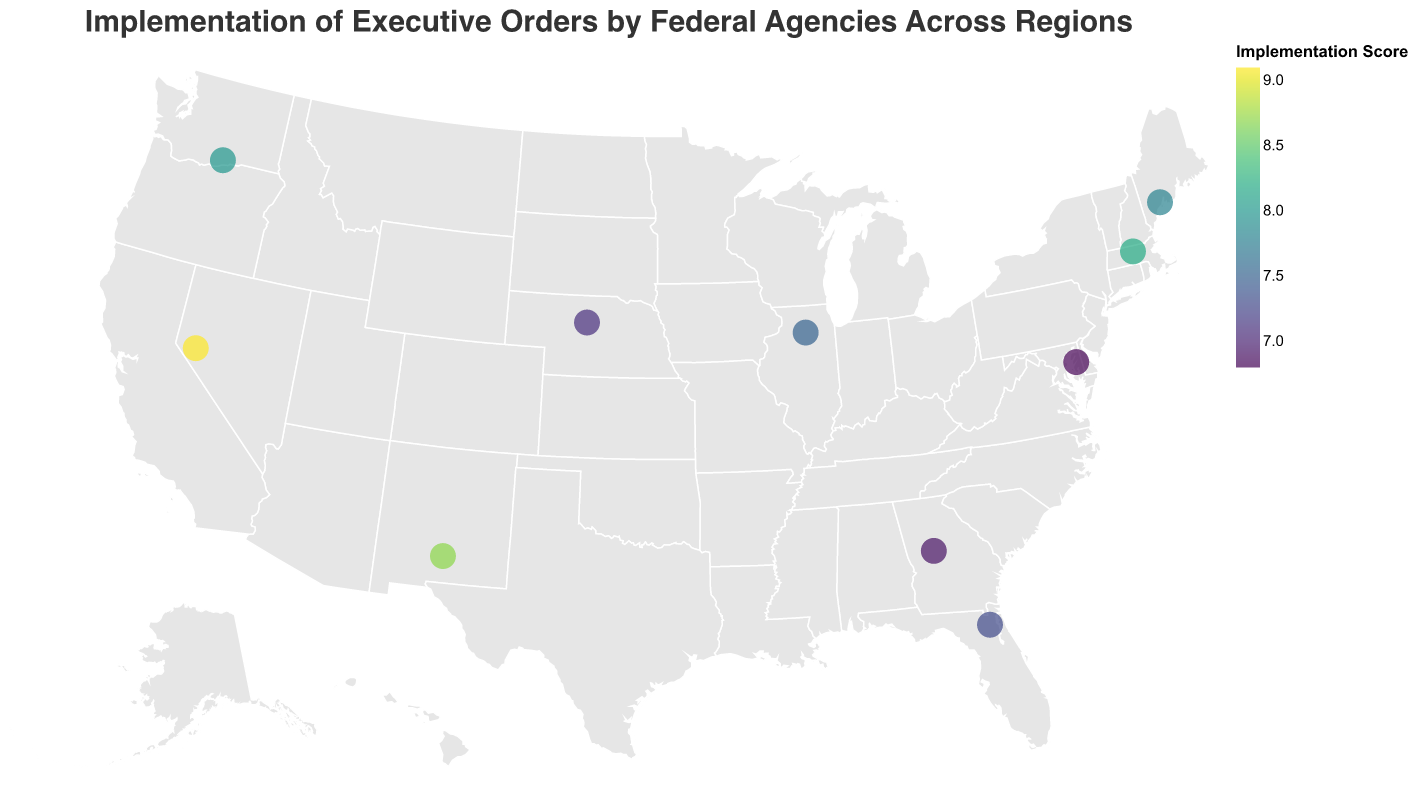what is the title of the plot? The title is usually displayed at the top of the plot. Here, it indicates the main topic, which is the implementation of executive orders by federal agencies across different regions.
Answer: Implementation of Executive Orders by Federal Agencies Across Regions How many data points are plotted on the map? Counting the number of circles on the map, each representing a data point, leads to finding the total number.
Answer: 10 Which agency has the highest implementation score and in which region is it located? The color intensity and tooltip can indicate the highest implementation score, which belongs to the Department of the Interior in the West region.
Answer: Department of the Interior, West What is the general color scheme used to represent the implementation scores? The legend on the plot indicates that a viridis color scheme is used, where lighter colors represent lower scores and darker colors represent higher scores.
Answer: Viridis Which region has the lowest implementation score and what is the score? By examining the tooltips and color intensity, the lowest implementation score belongs to the Mid-Atlantic region with a score of 6.8.
Answer: Mid-Atlantic, 6.8 How does the implementation score of the Department of Homeland Security in the Northeast compare to the Department of Labor in the Southeast? Comparing the tooltip values, the Department of Homeland Security in the Northeast has a higher score (8.2) than the Department of Labor in the Southeast (7.3).
Answer: Higher What is the average implementation score of all the regions combined? Calculating the mean of all implementation scores: (8.2 + 7.5 + 6.9 + 9.1 + 8.7 + 7.3 + 6.8 + 8.0 + 7.8 + 7.1) / 10 = 7.74
Answer: 7.74 Which regions have an implementation score greater than 8? By checking the color intensity and tooltips, the regions with scores greater than 8 are the Northeast, West, Southwest, and Pacific Northwest.
Answer: Northeast, West, Southwest, Pacific Northwest In which regions do Environmental Protection Agency and Department of Agriculture operate, and what are their respective implementation scores? The tooltips indicate that the Environmental Protection Agency operates in the Midwest with a score of 7.5 and the Department of Agriculture operates in the Pacific Northwest with a score of 8.0.
Answer: Midwest, 7.5 and Pacific Northwest, 8.0 What is the median implementation score across all the regions? Arranging the scores in ascending order (6.8, 6.9, 7.1, 7.3, 7.5, 7.8, 8.0, 8.2, 8.7, 9.1) and finding the middle value gives 7.65, the average of 7.5 and 7.8.
Answer: 7.65 